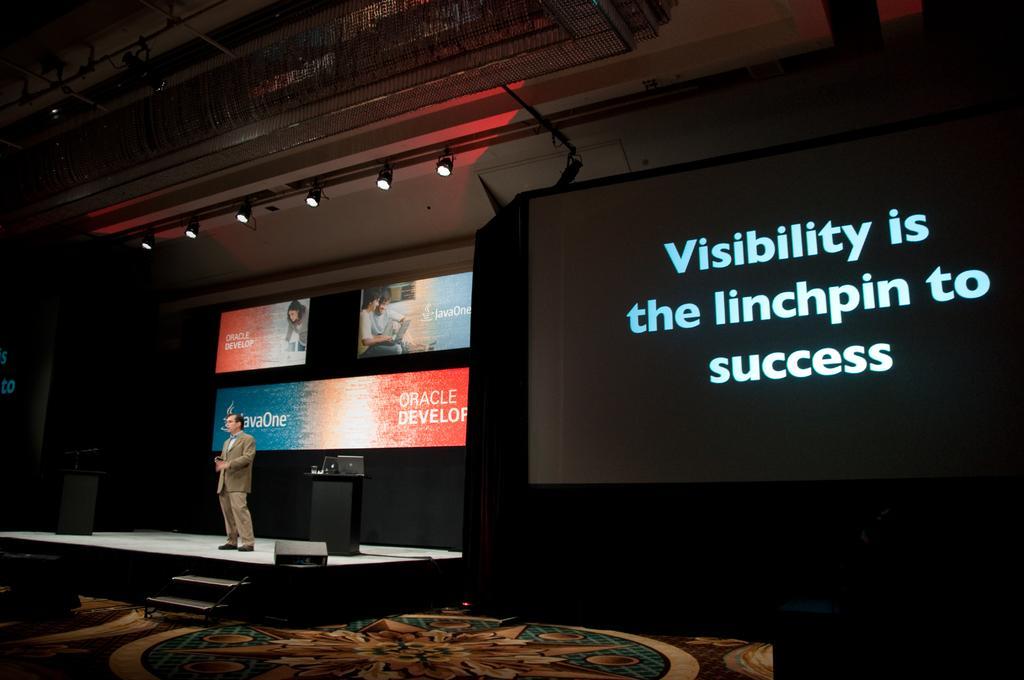Please provide a concise description of this image. In the center of the image there is a person standing on the stage. There is a podium. In the background of the image there is a screen. At the top of the image there is ceiling with lights. At the bottom of the image there is a carpet. To the right side of the image there is a screen. 